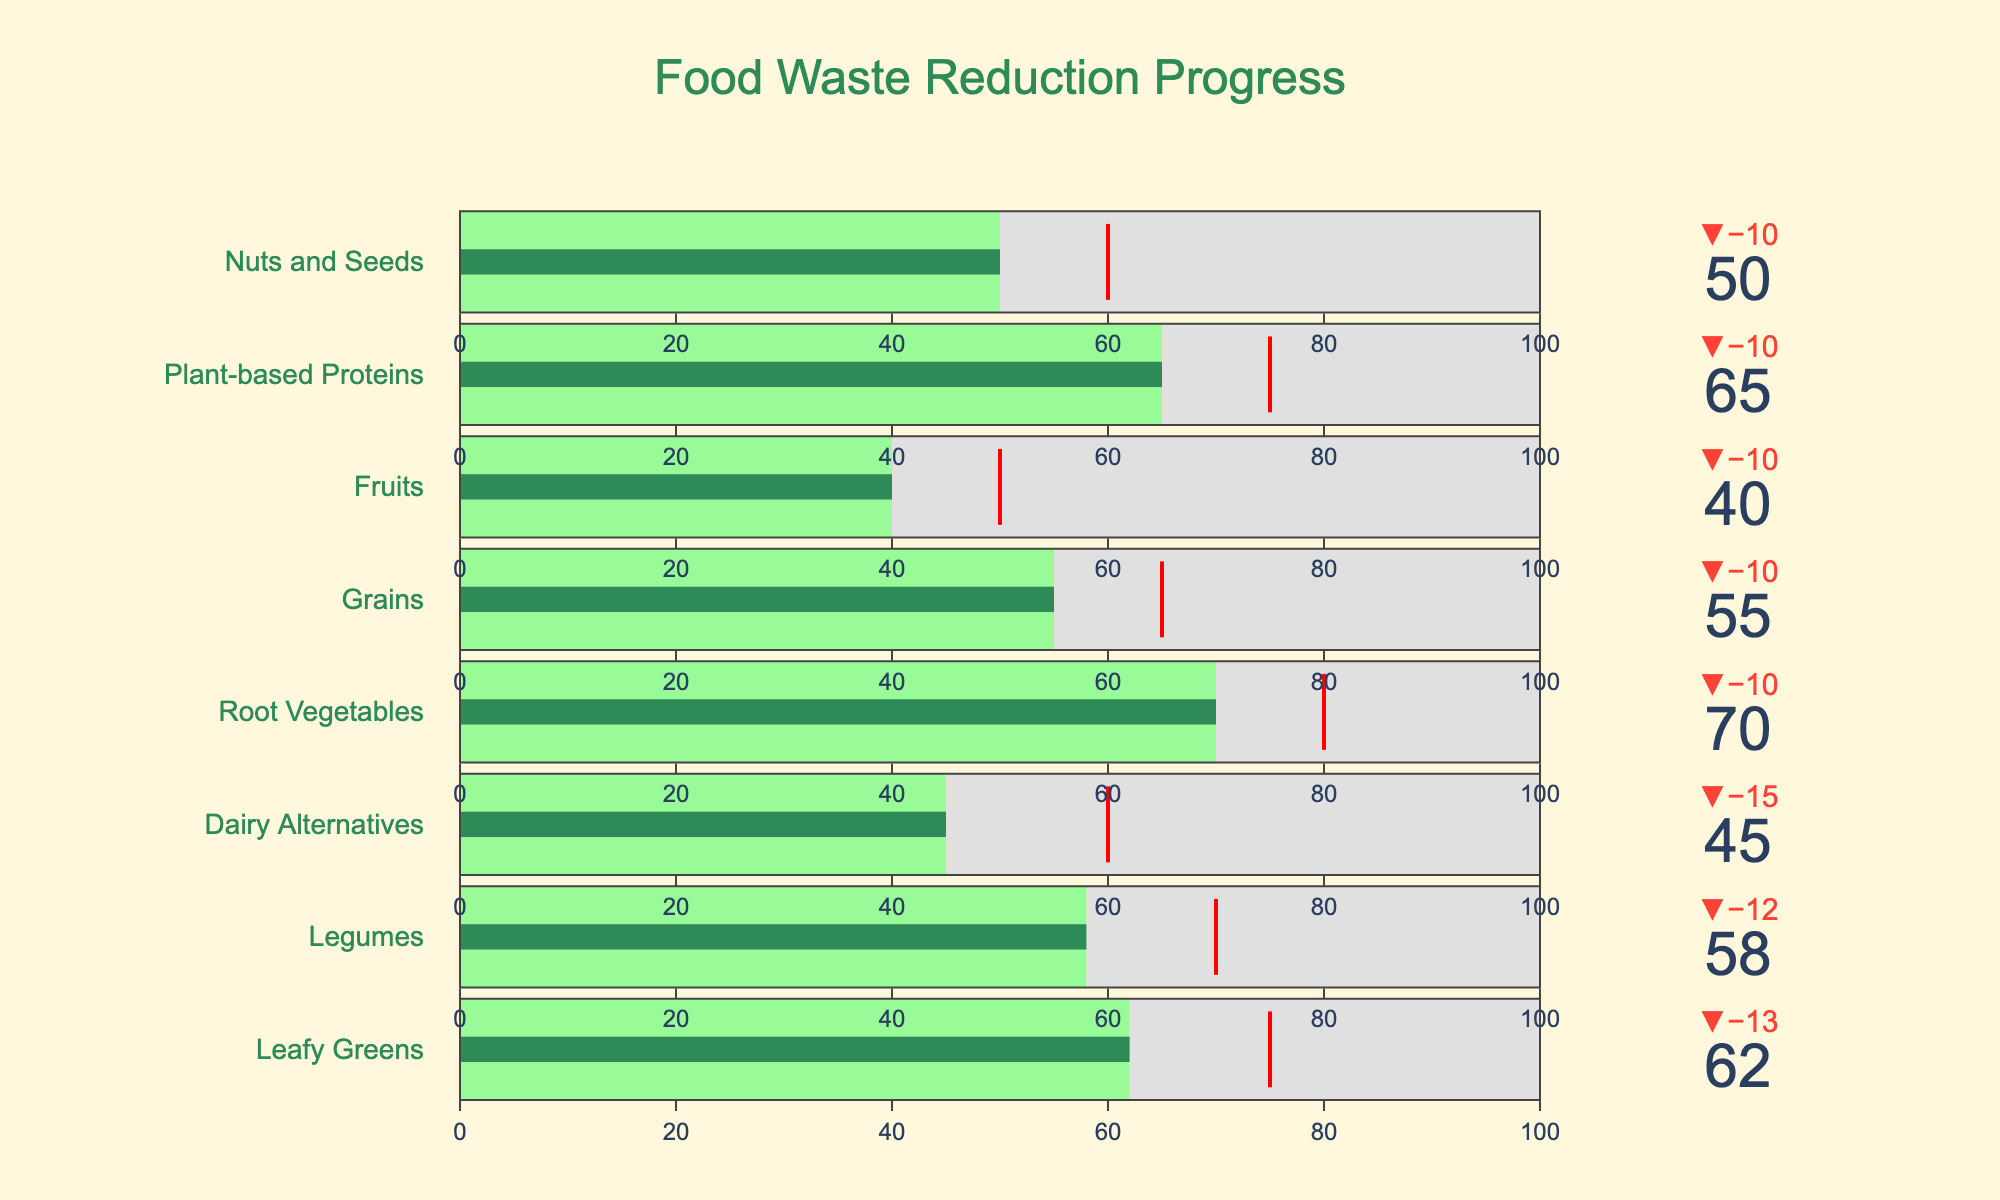Which ingredient type has the highest actual reduction percentage? By looking at the gauges, Root Vegetables have the highest actual reduction percentage, as indicated by the green bar reaching the highest value.
Answer: Root Vegetables What is the target reduction percentage for Dairy Alternatives? The target reduction percentage for Dairy Alternatives can be read directly from the gauge, where a red threshold line is set.
Answer: 60% How much more reduction is needed for Leafy Greens to hit the target? The actual reduction percentage for Leafy Greens is 62%, and the target is 75%. Subtracting the actual reduction from the target gives 75% - 62% = 13%.
Answer: 13% Which ingredient type has an actual reduction closest to its target? By comparing the delta indicators of all ingredients, we see that Leafy Greens have a delta close to 0, as its actual reduction is closest to its target reduction.
Answer: Leafy Greens What is the average target reduction percentage for all ingredient types? Add all target percentages: 75 + 70 + 60 + 80 + 65 + 50 + 75 + 60 = 535. Divide by the number of ingredients: 535 / 8 = 66.875%
Answer: 66.875% Which ingredient type is performing worst relative to its target? Compare the delta values for all ingredient types: Fruits have the highest negative delta value, indicating the largest shortfall from its target.
Answer: Fruits Are any ingredients exceeding their target reduction percentages? By observing the delta values, none of the gauges have a positive delta; thus, no ingredient exceeds its target reduction.
Answer: No What is the difference between the highest and lowest actual reduction percentages? The highest actual reduction percentage is for Root Vegetables at 70% and the lowest is for Fruits at 40%. The difference is 70% - 40% = 30%.
Answer: 30% How many ingredient types have an actual reduction percentage equal to or greater than 60%? Leafy Greens, Legumes, Root Vegetables, and Plant-Based Proteins have actual reductions of 62%, 58%, 70%, and 65% respectively. Three of these (other than Legumes) meet or exceed 60%.
Answer: 3 What is the most common color used to represent actual reduction percentages? The color for the actual reduction percentages on the gauges is predominantly green, used to show the extent of reduction achieved. This green color denotes the actual reduction on the bullet charts.
Answer: Green 